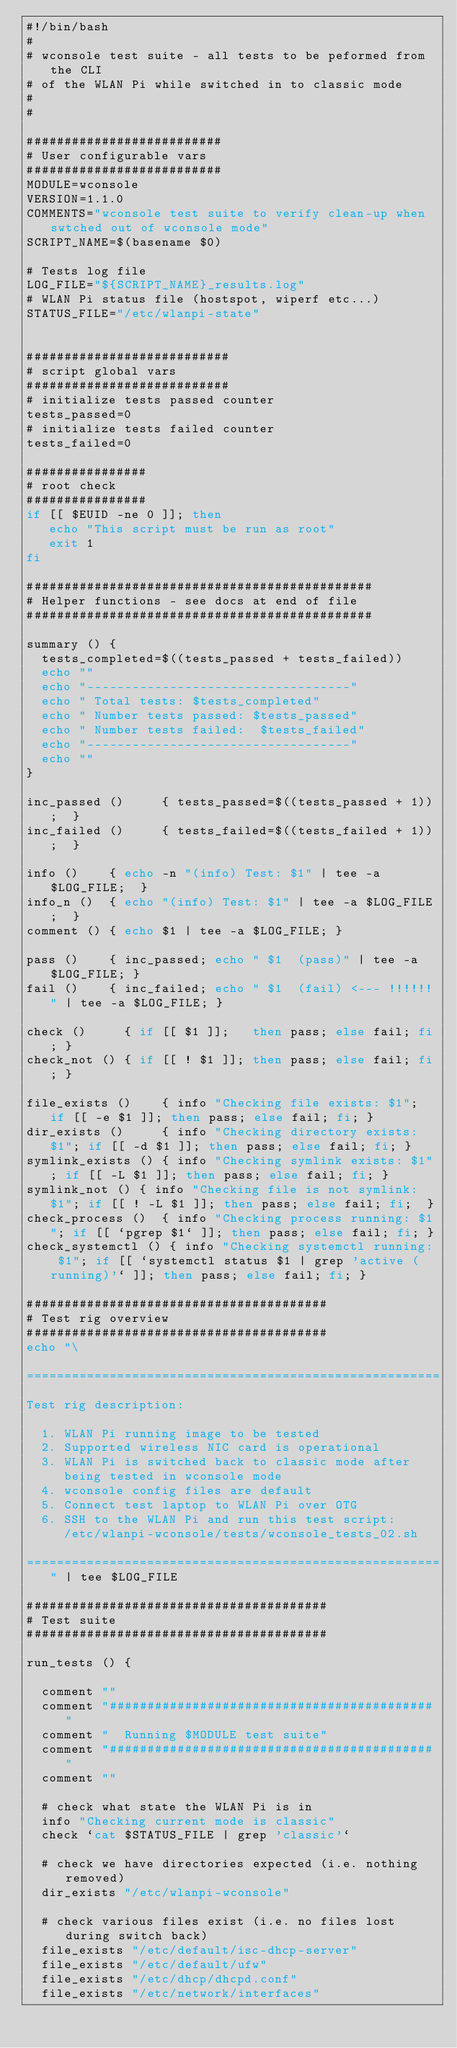Convert code to text. <code><loc_0><loc_0><loc_500><loc_500><_Bash_>#!/bin/bash
#
# wconsole test suite - all tests to be peformed from the CLI 
# of the WLAN Pi while switched in to classic mode
#
#

##########################
# User configurable vars
##########################
MODULE=wconsole
VERSION=1.1.0
COMMENTS="wconsole test suite to verify clean-up when swtched out of wconsole mode"
SCRIPT_NAME=$(basename $0)

# Tests log file
LOG_FILE="${SCRIPT_NAME}_results.log"
# WLAN Pi status file (hostspot, wiperf etc...)
STATUS_FILE="/etc/wlanpi-state"


###########################
# script global vars
###########################
# initialize tests passed counter
tests_passed=0
# initialize tests failed counter
tests_failed=0

################
# root check
################
if [[ $EUID -ne 0 ]]; then
   echo "This script must be run as root" 
   exit 1
fi

##############################################
# Helper functions - see docs at end of file
##############################################

summary () {
  tests_completed=$((tests_passed + tests_failed))
  echo ""
  echo "-----------------------------------"
  echo " Total tests: $tests_completed"
  echo " Number tests passed: $tests_passed"
  echo " Number tests failed:  $tests_failed"
  echo "-----------------------------------"
  echo ""
}

inc_passed ()     { tests_passed=$((tests_passed + 1));  }
inc_failed ()     { tests_failed=$((tests_failed + 1));  }

info ()    { echo -n "(info) Test: $1" | tee -a $LOG_FILE;  }
info_n ()  { echo "(info) Test: $1" | tee -a $LOG_FILE;  }
comment () { echo $1 | tee -a $LOG_FILE; }

pass ()    { inc_passed; echo " $1  (pass)" | tee -a $LOG_FILE; }
fail ()    { inc_failed; echo " $1  (fail) <--- !!!!!!" | tee -a $LOG_FILE; }

check ()     { if [[ $1 ]];   then pass; else fail; fi; }
check_not () { if [[ ! $1 ]]; then pass; else fail; fi; }

file_exists ()    { info "Checking file exists: $1"; if [[ -e $1 ]]; then pass; else fail; fi; }
dir_exists ()     { info "Checking directory exists: $1"; if [[ -d $1 ]]; then pass; else fail; fi; }
symlink_exists () { info "Checking symlink exists: $1"; if [[ -L $1 ]]; then pass; else fail; fi; }
symlink_not () { info "Checking file is not symlink: $1"; if [[ ! -L $1 ]]; then pass; else fail; fi;  }
check_process ()  { info "Checking process running: $1"; if [[ `pgrep $1` ]]; then pass; else fail; fi; }
check_systemctl () { info "Checking systemctl running: $1"; if [[ `systemctl status $1 | grep 'active (running)'` ]]; then pass; else fail; fi; }

########################################
# Test rig overview
########################################
echo "\

=======================================================
Test rig description:

  1. WLAN Pi running image to be tested
  2. Supported wireless NIC card is operational
  3. WLAN Pi is switched back to classic mode after 
     being tested in wconsole mode
  4. wconsole config files are default
  5. Connect test laptop to WLAN Pi over OTG
  6. SSH to the WLAN Pi and run this test script:
     /etc/wlanpi-wconsole/tests/wconsole_tests_02.sh

=======================================================" | tee $LOG_FILE

########################################
# Test suite
########################################

run_tests () {

  comment ""
  comment "###########################################"
  comment "  Running $MODULE test suite"
  comment "###########################################"
  comment ""

  # check what state the WLAN Pi is in
  info "Checking current mode is classic"
  check `cat $STATUS_FILE | grep 'classic'`

  # check we have directories expected (i.e. nothing removed)
  dir_exists "/etc/wlanpi-wconsole"

  # check various files exist (i.e. no files lost during switch back)
  file_exists "/etc/default/isc-dhcp-server"
  file_exists "/etc/default/ufw"
  file_exists "/etc/dhcp/dhcpd.conf"
  file_exists "/etc/network/interfaces"</code> 